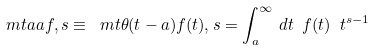<formula> <loc_0><loc_0><loc_500><loc_500>\ m t a { a } { f , s } \equiv \ m t { \theta ( t - a ) f ( t ) , s } = \int _ { a } ^ { \infty } \, d t \ f ( t ) \ t ^ { s - 1 }</formula> 